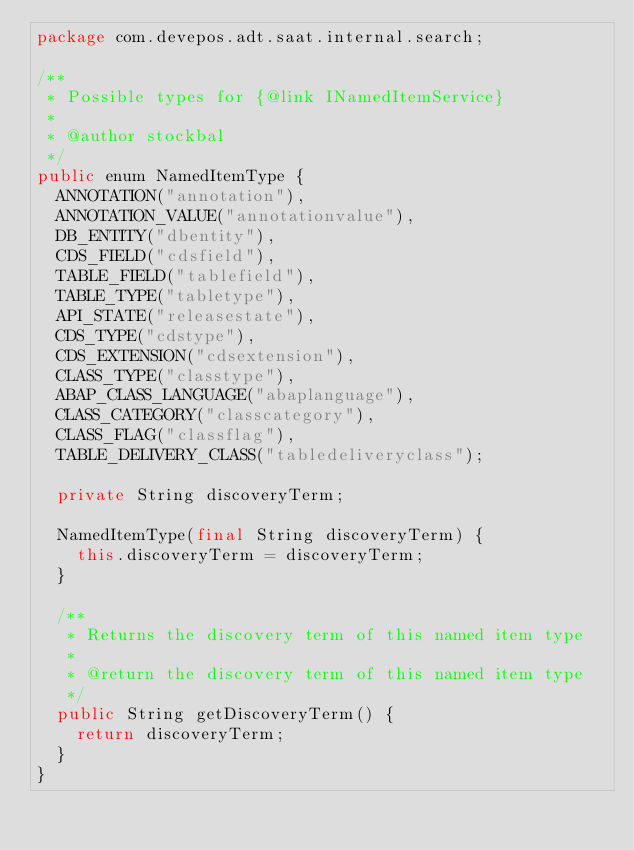Convert code to text. <code><loc_0><loc_0><loc_500><loc_500><_Java_>package com.devepos.adt.saat.internal.search;

/**
 * Possible types for {@link INamedItemService}
 *
 * @author stockbal
 */
public enum NamedItemType {
  ANNOTATION("annotation"),
  ANNOTATION_VALUE("annotationvalue"),
  DB_ENTITY("dbentity"),
  CDS_FIELD("cdsfield"),
  TABLE_FIELD("tablefield"),
  TABLE_TYPE("tabletype"),
  API_STATE("releasestate"),
  CDS_TYPE("cdstype"),
  CDS_EXTENSION("cdsextension"),
  CLASS_TYPE("classtype"),
  ABAP_CLASS_LANGUAGE("abaplanguage"),
  CLASS_CATEGORY("classcategory"),
  CLASS_FLAG("classflag"),
  TABLE_DELIVERY_CLASS("tabledeliveryclass");

  private String discoveryTerm;

  NamedItemType(final String discoveryTerm) {
    this.discoveryTerm = discoveryTerm;
  }

  /**
   * Returns the discovery term of this named item type
   *
   * @return the discovery term of this named item type
   */
  public String getDiscoveryTerm() {
    return discoveryTerm;
  }
}</code> 